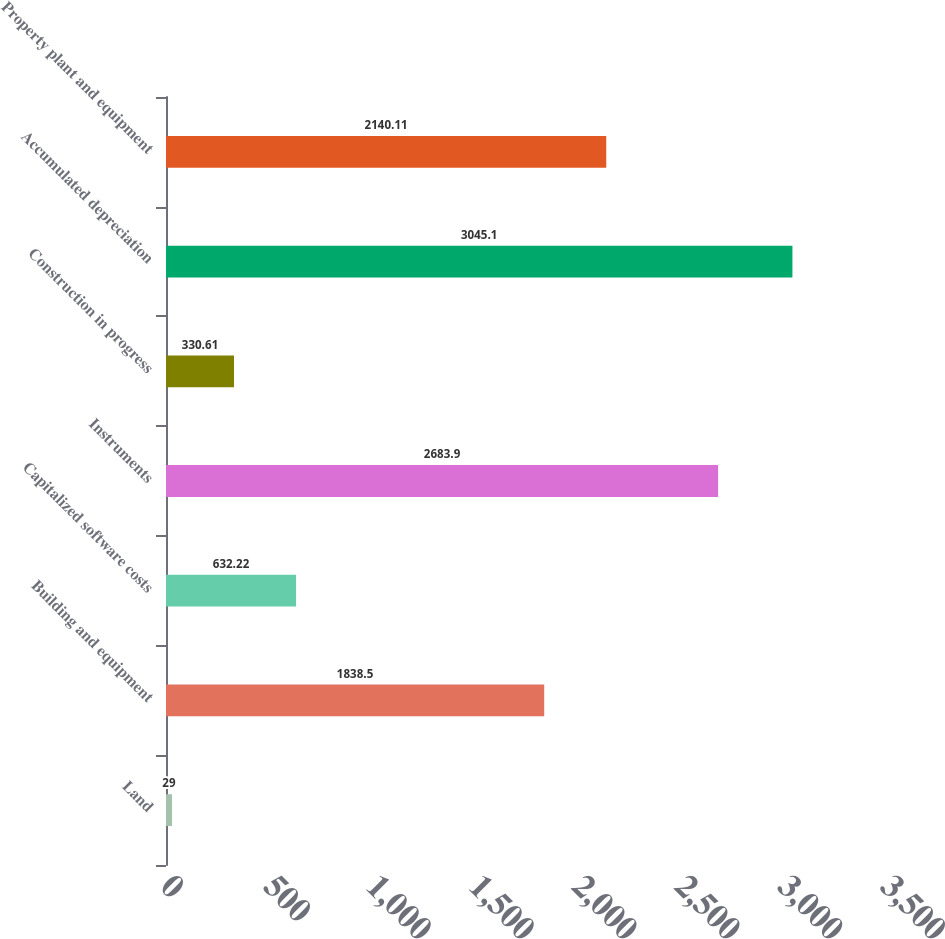Convert chart to OTSL. <chart><loc_0><loc_0><loc_500><loc_500><bar_chart><fcel>Land<fcel>Building and equipment<fcel>Capitalized software costs<fcel>Instruments<fcel>Construction in progress<fcel>Accumulated depreciation<fcel>Property plant and equipment<nl><fcel>29<fcel>1838.5<fcel>632.22<fcel>2683.9<fcel>330.61<fcel>3045.1<fcel>2140.11<nl></chart> 